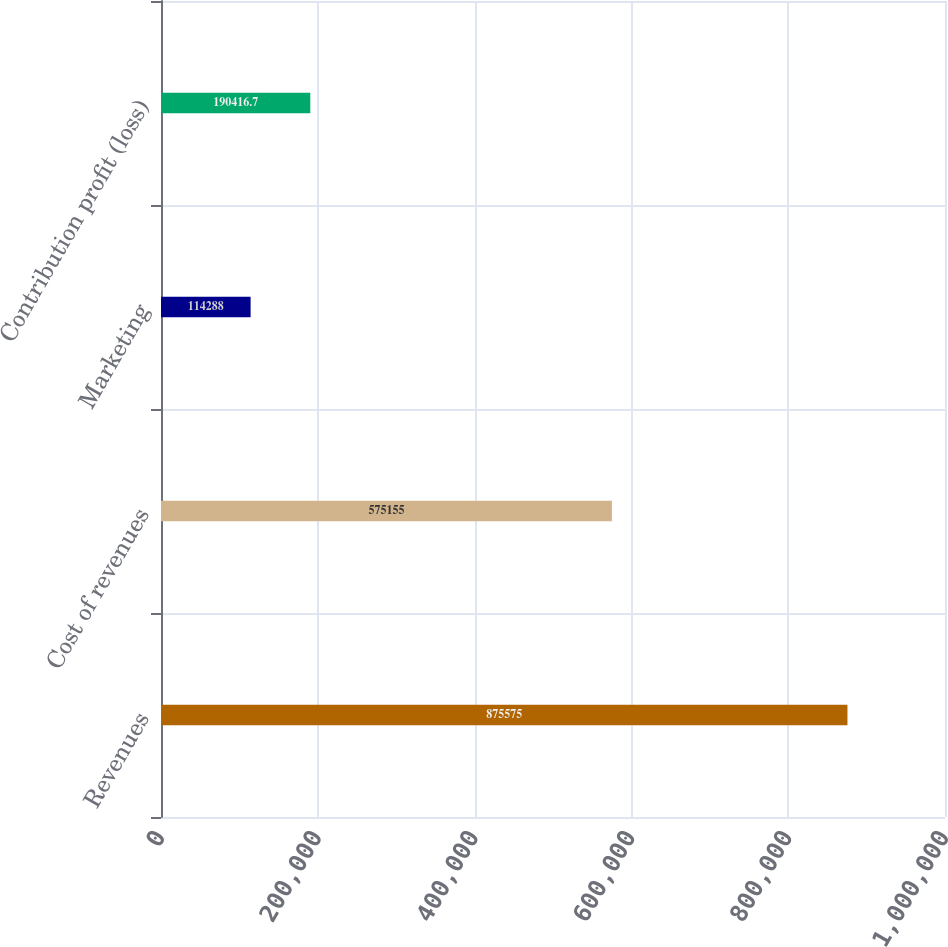Convert chart. <chart><loc_0><loc_0><loc_500><loc_500><bar_chart><fcel>Revenues<fcel>Cost of revenues<fcel>Marketing<fcel>Contribution profit (loss)<nl><fcel>875575<fcel>575155<fcel>114288<fcel>190417<nl></chart> 